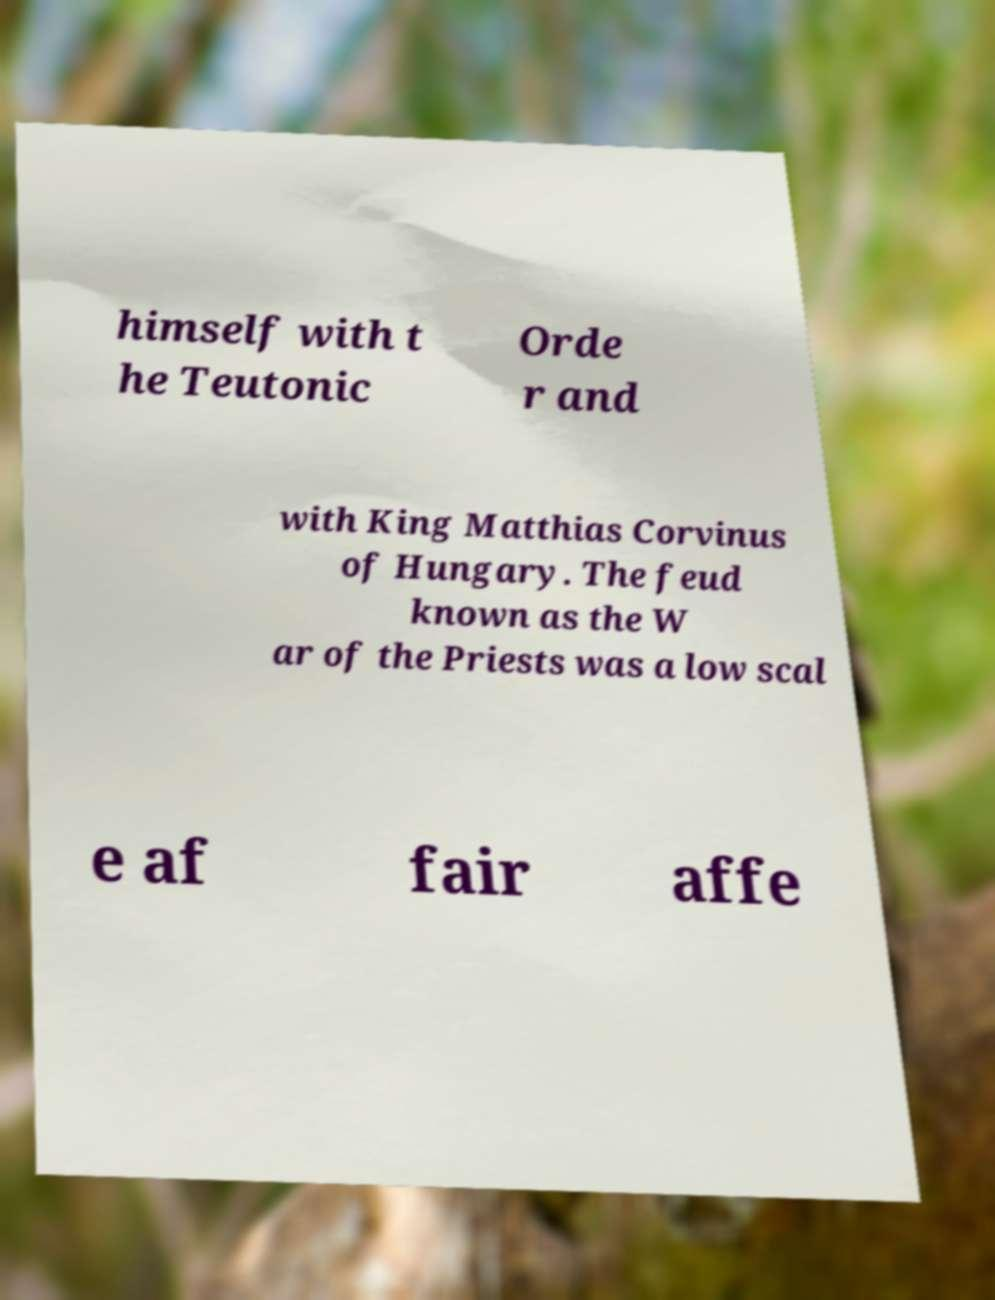For documentation purposes, I need the text within this image transcribed. Could you provide that? himself with t he Teutonic Orde r and with King Matthias Corvinus of Hungary. The feud known as the W ar of the Priests was a low scal e af fair affe 